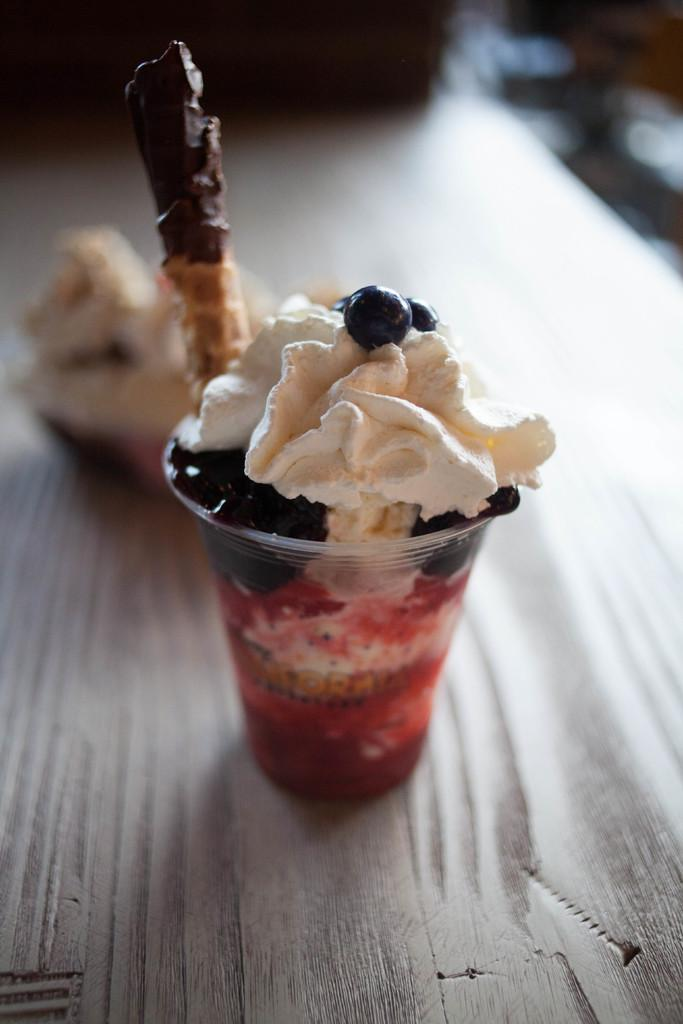What is the main subject of the image? The main subject of the image is ice cream. Where is the ice cream located in the image? The ice cream is in the center of the image. Is the ice cream on a specific surface? Yes, the ice cream is on a surface. How many sisters are standing next to the ice cream in the image? There are no sisters present in the image; it only features ice cream on a surface. What type of apple can be seen growing on the ice cream in the image? There is no apple present in the image; it only features ice cream on a surface. 